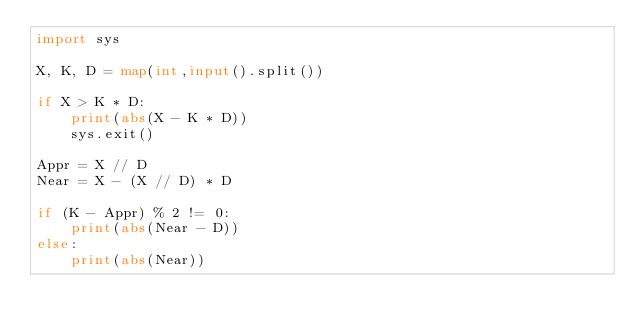<code> <loc_0><loc_0><loc_500><loc_500><_Python_>import sys

X, K, D = map(int,input().split())

if X > K * D:
    print(abs(X - K * D))
    sys.exit()

Appr = X // D
Near = X - (X // D) * D

if (K - Appr) % 2 != 0:
    print(abs(Near - D))
else:
    print(abs(Near))</code> 